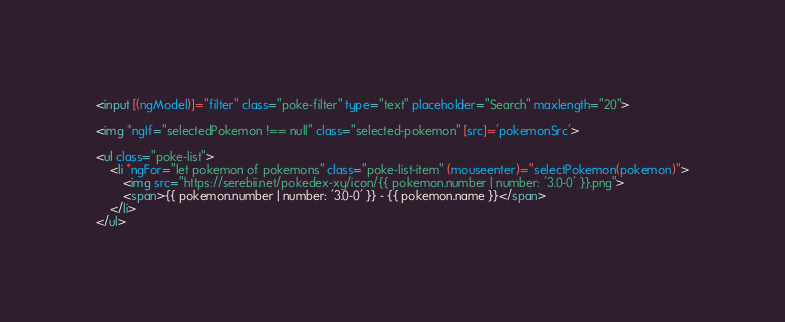Convert code to text. <code><loc_0><loc_0><loc_500><loc_500><_HTML_><input [(ngModel)]="filter" class="poke-filter" type="text" placeholder="Search" maxlength="20">

<img *ngIf="selectedPokemon !== null" class="selected-pokemon" [src]='pokemonSrc'>

<ul class="poke-list">
    <li *ngFor="let pokemon of pokemons" class="poke-list-item" (mouseenter)="selectPokemon(pokemon)">
        <img src="https://serebii.net/pokedex-xy/icon/{{ pokemon.number | number: '3.0-0' }}.png">
        <span>{{ pokemon.number | number: '3.0-0' }} - {{ pokemon.name }}</span>
    </li>
</ul></code> 